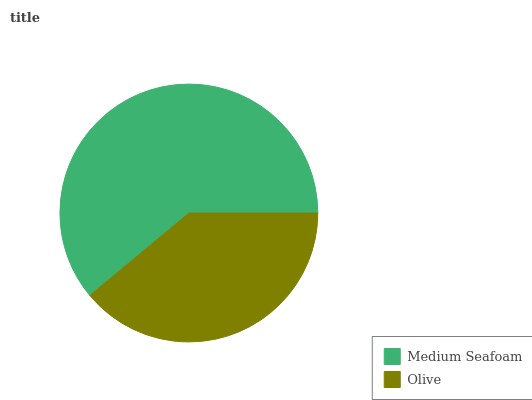Is Olive the minimum?
Answer yes or no. Yes. Is Medium Seafoam the maximum?
Answer yes or no. Yes. Is Olive the maximum?
Answer yes or no. No. Is Medium Seafoam greater than Olive?
Answer yes or no. Yes. Is Olive less than Medium Seafoam?
Answer yes or no. Yes. Is Olive greater than Medium Seafoam?
Answer yes or no. No. Is Medium Seafoam less than Olive?
Answer yes or no. No. Is Medium Seafoam the high median?
Answer yes or no. Yes. Is Olive the low median?
Answer yes or no. Yes. Is Olive the high median?
Answer yes or no. No. Is Medium Seafoam the low median?
Answer yes or no. No. 